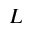Convert formula to latex. <formula><loc_0><loc_0><loc_500><loc_500>L</formula> 